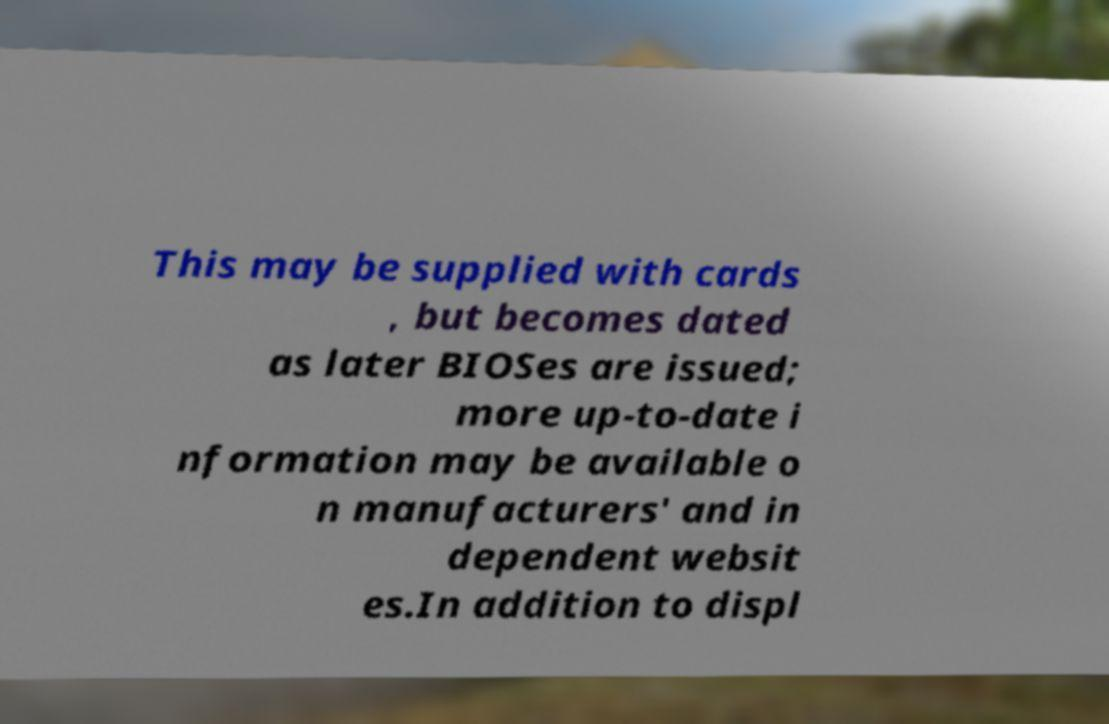Please read and relay the text visible in this image. What does it say? This may be supplied with cards , but becomes dated as later BIOSes are issued; more up-to-date i nformation may be available o n manufacturers' and in dependent websit es.In addition to displ 